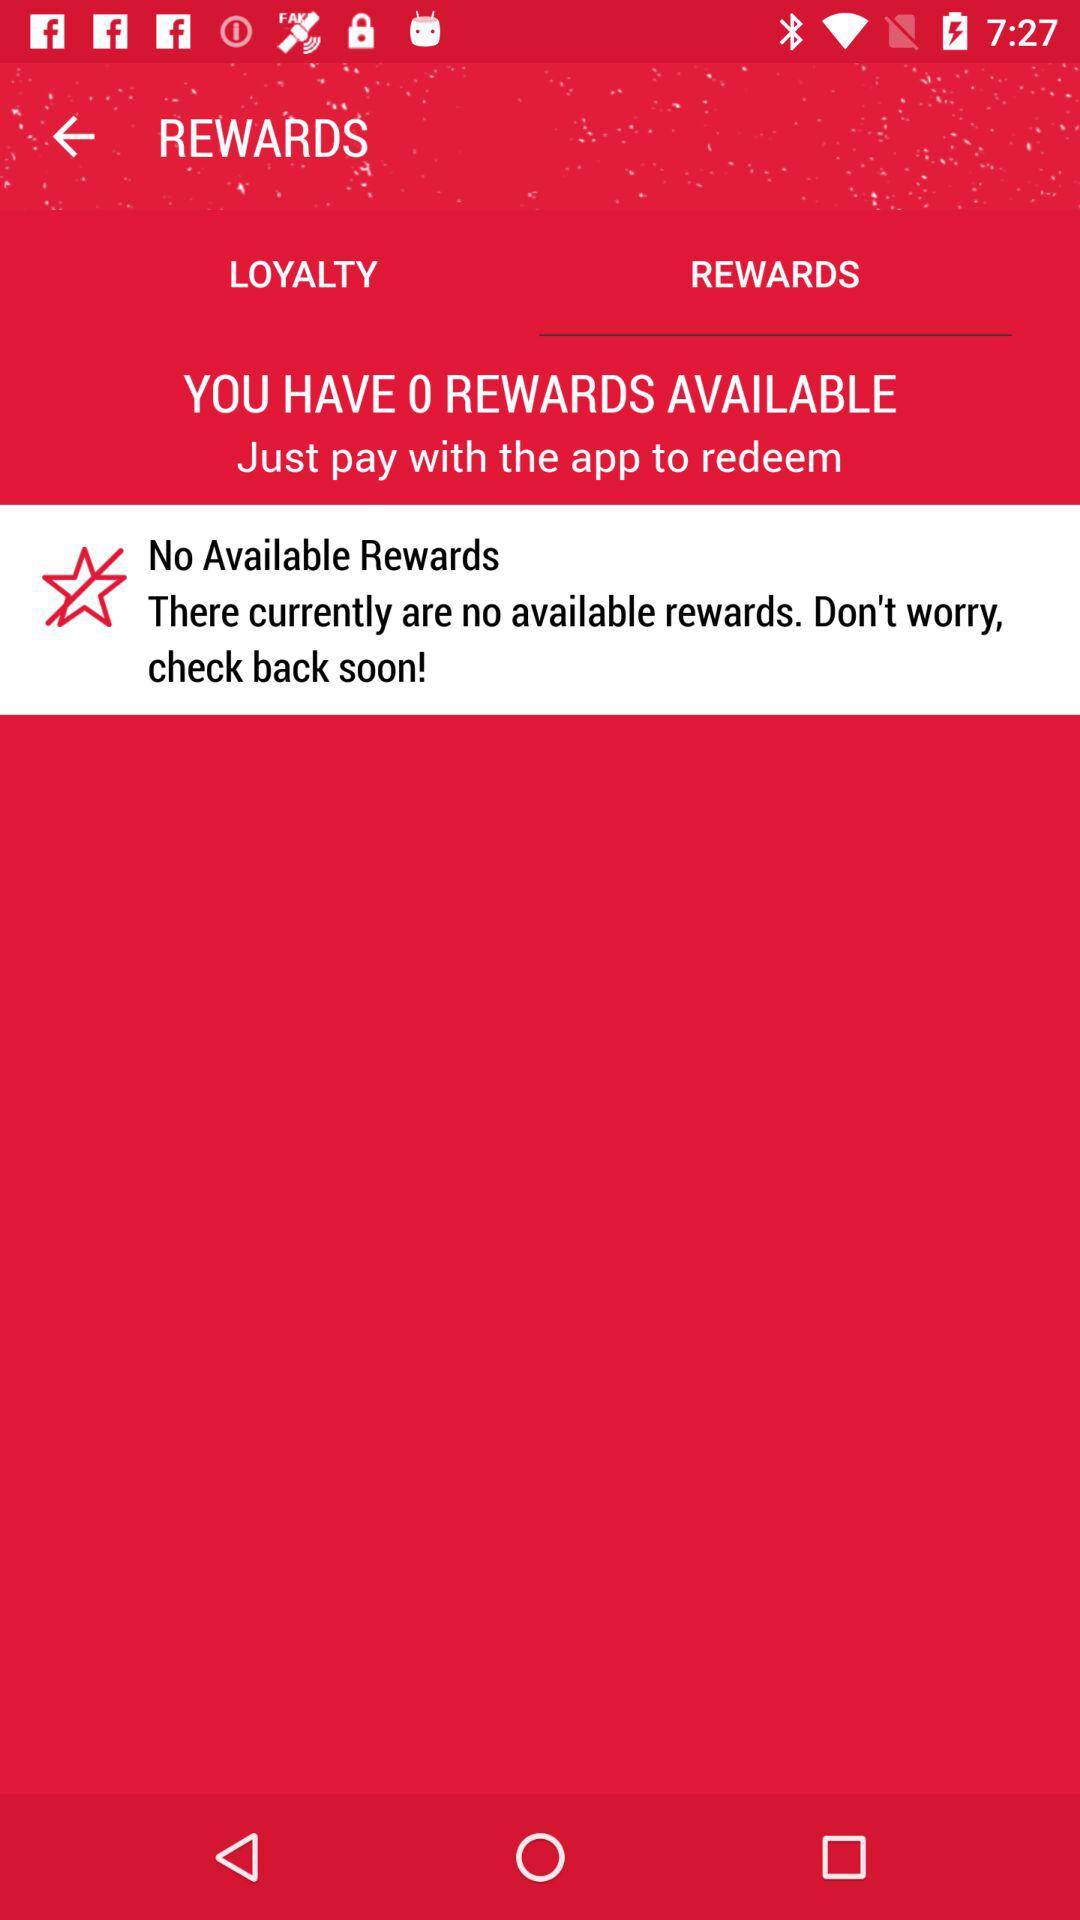What is the application name?
When the provided information is insufficient, respond with <no answer>. <no answer> 